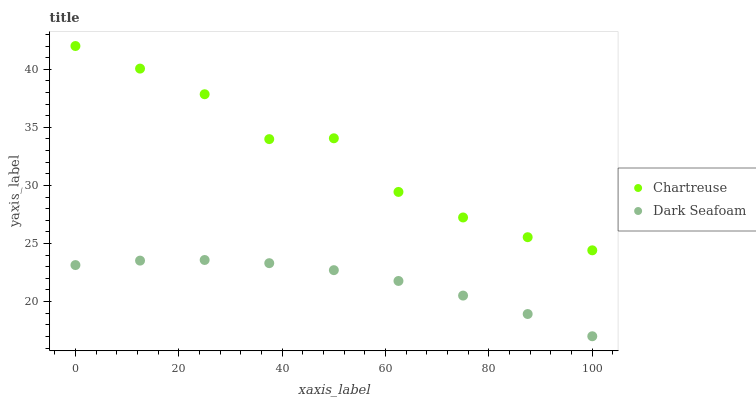Does Dark Seafoam have the minimum area under the curve?
Answer yes or no. Yes. Does Chartreuse have the maximum area under the curve?
Answer yes or no. Yes. Does Dark Seafoam have the maximum area under the curve?
Answer yes or no. No. Is Dark Seafoam the smoothest?
Answer yes or no. Yes. Is Chartreuse the roughest?
Answer yes or no. Yes. Is Dark Seafoam the roughest?
Answer yes or no. No. Does Dark Seafoam have the lowest value?
Answer yes or no. Yes. Does Chartreuse have the highest value?
Answer yes or no. Yes. Does Dark Seafoam have the highest value?
Answer yes or no. No. Is Dark Seafoam less than Chartreuse?
Answer yes or no. Yes. Is Chartreuse greater than Dark Seafoam?
Answer yes or no. Yes. Does Dark Seafoam intersect Chartreuse?
Answer yes or no. No. 